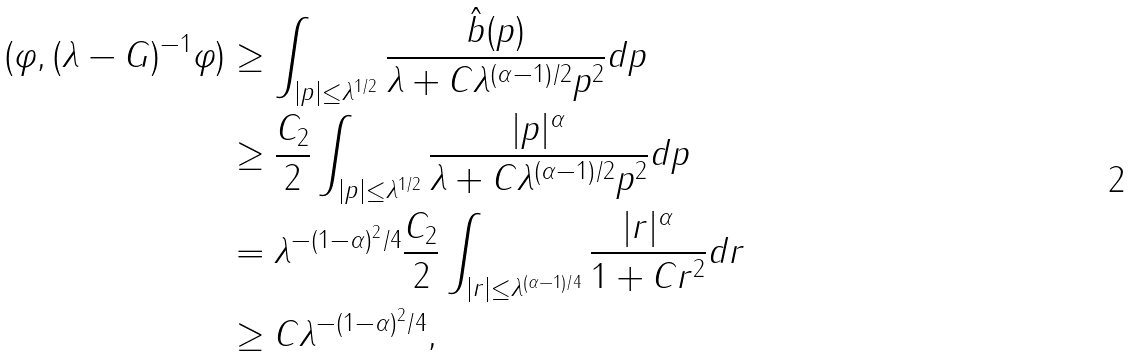Convert formula to latex. <formula><loc_0><loc_0><loc_500><loc_500>( \varphi , ( \lambda - G ) ^ { - 1 } \varphi ) & \geq \int _ { | p | \leq \lambda ^ { 1 / 2 } } \frac { \hat { b } ( p ) } { \lambda + C \lambda ^ { ( \alpha - 1 ) / 2 } p ^ { 2 } } d p \\ & \geq \frac { C _ { 2 } } { 2 } \int _ { | p | \leq \lambda ^ { 1 / 2 } } \frac { | p | ^ { \alpha } } { \lambda + C \lambda ^ { ( \alpha - 1 ) / 2 } p ^ { 2 } } d p \\ & = \lambda ^ { - ( 1 - \alpha ) ^ { 2 } / 4 } \frac { C _ { 2 } } { 2 } \int _ { | r | \leq \lambda ^ { ( \alpha - 1 ) / 4 } } \frac { | r | ^ { \alpha } } { 1 + C r ^ { 2 } } d r \\ & \geq C \lambda ^ { - ( 1 - \alpha ) ^ { 2 } / 4 } ,</formula> 